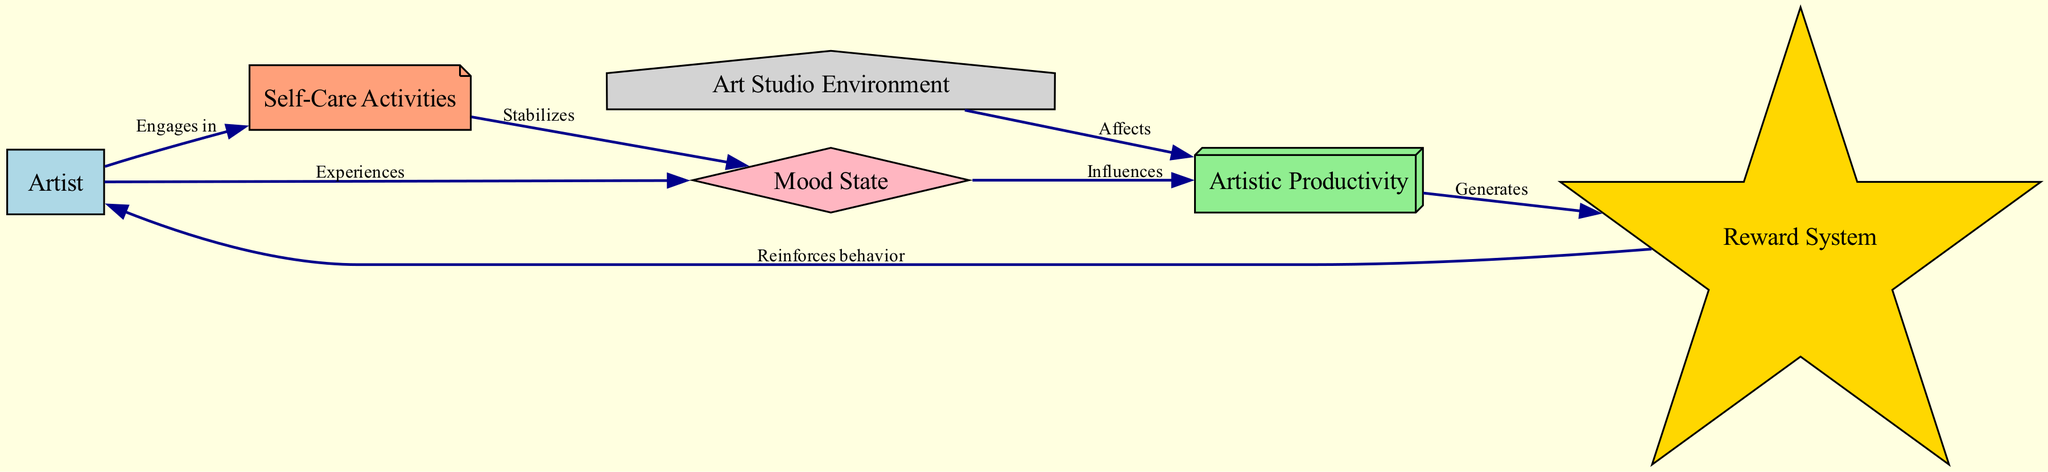What is the total number of nodes in the diagram? The diagram has six nodes: Artist, Mood State, Artistic Productivity, Self-Care Activities, Reward System, and Art Studio Environment. Counting these provides the total number of nodes.
Answer: 6 How does the mood state affect artistic productivity? According to the diagram, the mood state influences artistic productivity. The flow direction shows that mood state directly connects to artistic productivity, indicating a causal relationship.
Answer: Influences What label is given to the relationship between self-care and mood state? The relationship is labeled "Stabilizes," which indicates that self-care activities have a positive effect on the mood state. This label is found on the edge connecting self-care to mood state.
Answer: Stabilizes Which node generates the reward system? Artistic productivity is the node that generates the reward system. This can be determined by following the directed edge from artistic productivity to the reward system in the diagram.
Answer: Generates What two activities does the artist engage in according to the diagram? The artist engages in artistic productivity and self-care activities. This can be seen through the directed edges that lead from the artist node to both of these respective nodes.
Answer: Artistic productivity and self-care activities What is the impact of the environment on artistic productivity? The diagram indicates that the environment affects artistic productivity. The edge labeled "Affects" illustrates this connection, showing that the art studio environment plays a role in determining the level of artistic productivity.
Answer: Affects How does the reward system reinforce the artist's behavior? The diagram shows a direct relationship from the reward system back to the artist. This means the outcomes from the reward system provide positive feedback that encourages the artist's continued behavior in art-making, thus reinforcing it.
Answer: Reinforces behavior What shape is used to represent the mood state in the diagram? The mood state is represented by a diamond shape. The diagram includes specific shapes for each node, and the mood state is visually distinguished by this particular design.
Answer: Diamond 